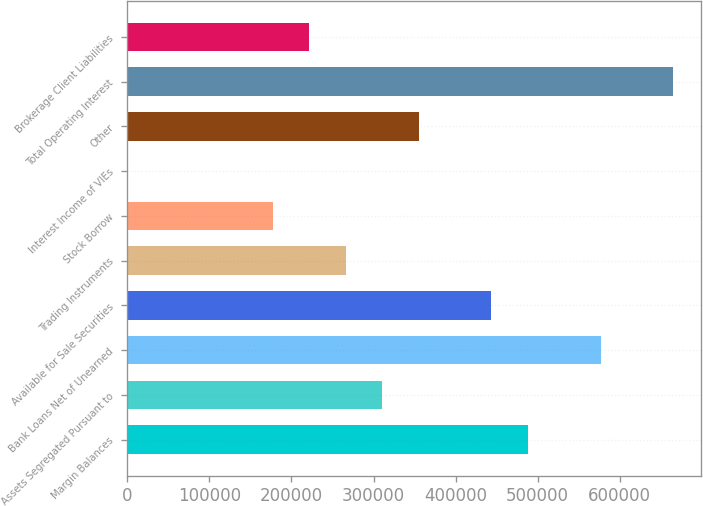<chart> <loc_0><loc_0><loc_500><loc_500><bar_chart><fcel>Margin Balances<fcel>Assets Segregated Pursuant to<fcel>Bank Loans Net of Unearned<fcel>Available for Sale Securities<fcel>Trading Instruments<fcel>Stock Borrow<fcel>Interest Income of VIEs<fcel>Other<fcel>Total Operating Interest<fcel>Brokerage Client Liabilities<nl><fcel>487935<fcel>310530<fcel>576638<fcel>443584<fcel>266179<fcel>177476<fcel>71<fcel>354881<fcel>665340<fcel>221828<nl></chart> 